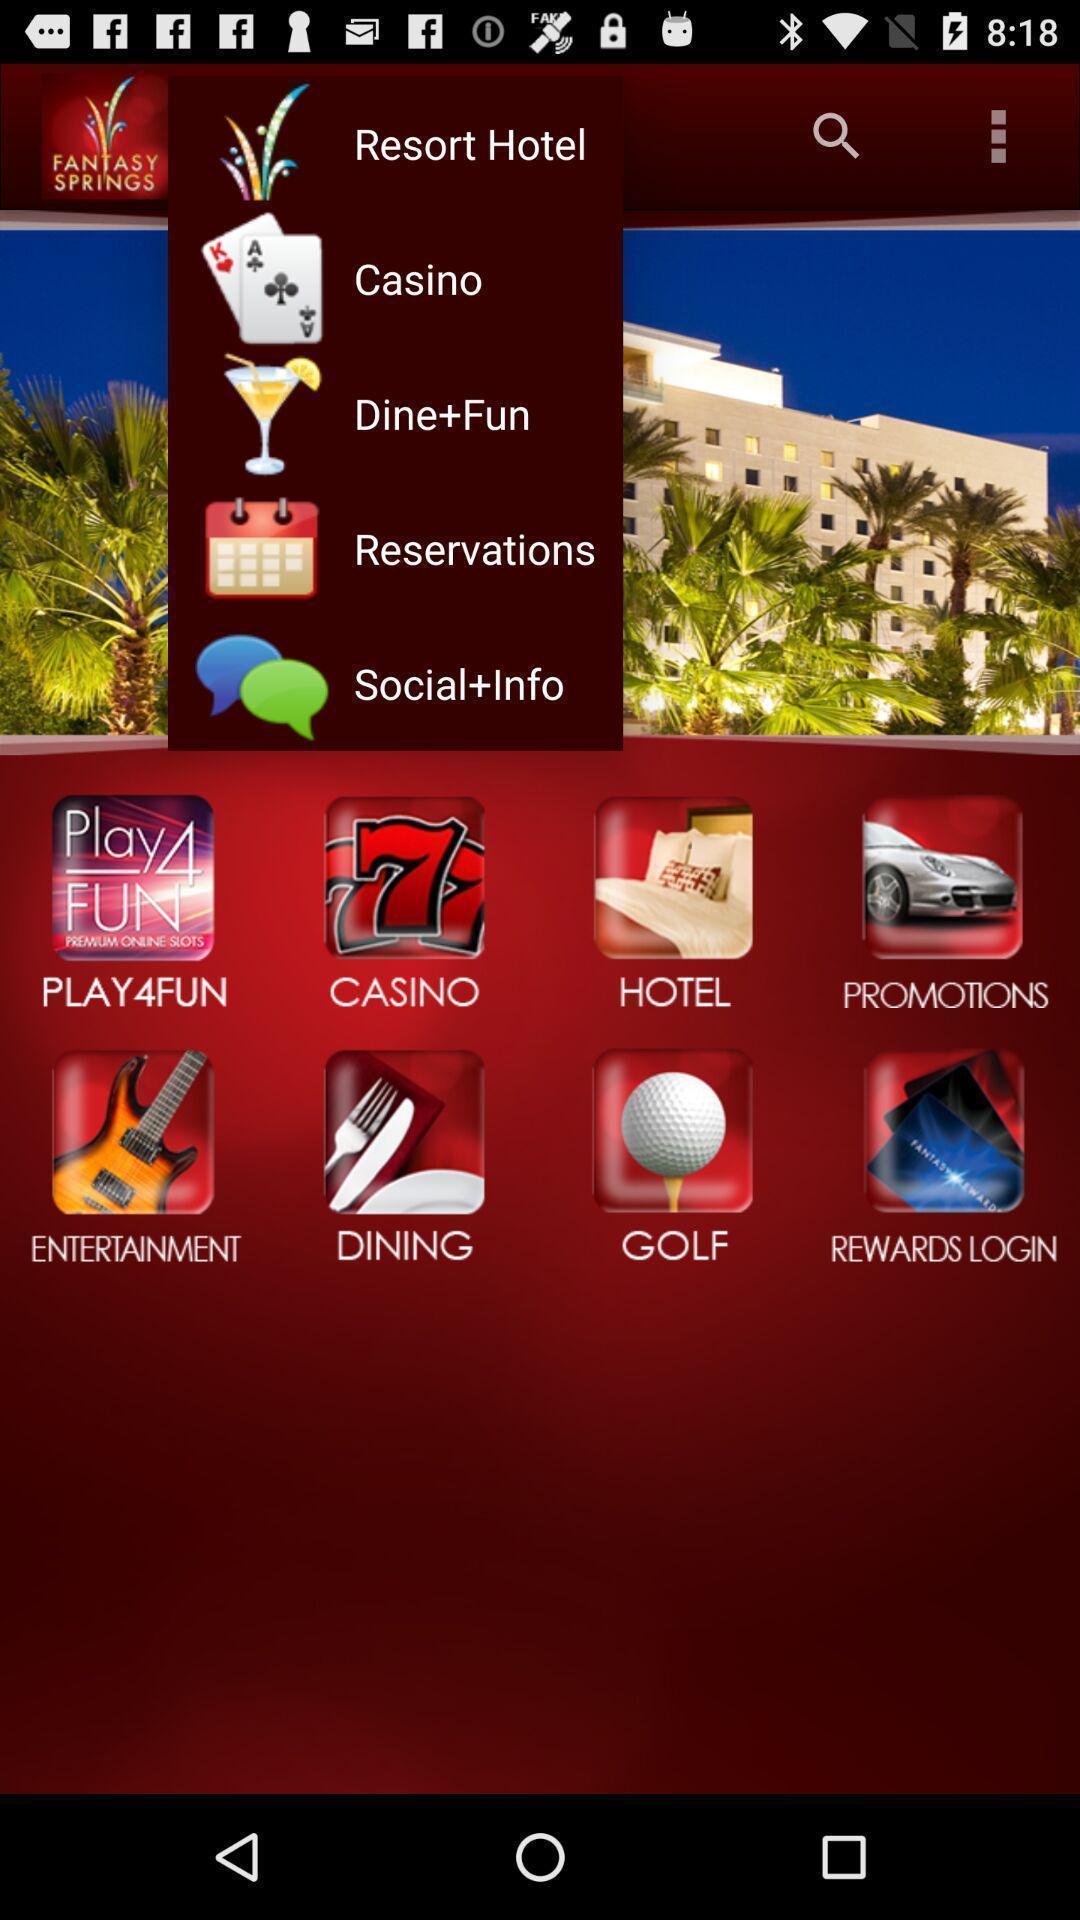Explain the elements present in this screenshot. Screen displaying the list of categories. 